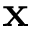<formula> <loc_0><loc_0><loc_500><loc_500>x</formula> 